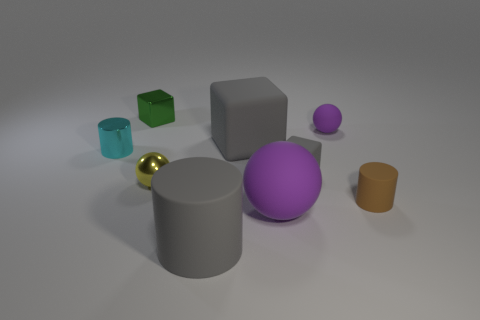Add 1 big blue cubes. How many objects exist? 10 Subtract 0 purple cubes. How many objects are left? 9 Subtract all blocks. How many objects are left? 6 Subtract all tiny red metallic things. Subtract all big gray rubber things. How many objects are left? 7 Add 2 metal objects. How many metal objects are left? 5 Add 2 balls. How many balls exist? 5 